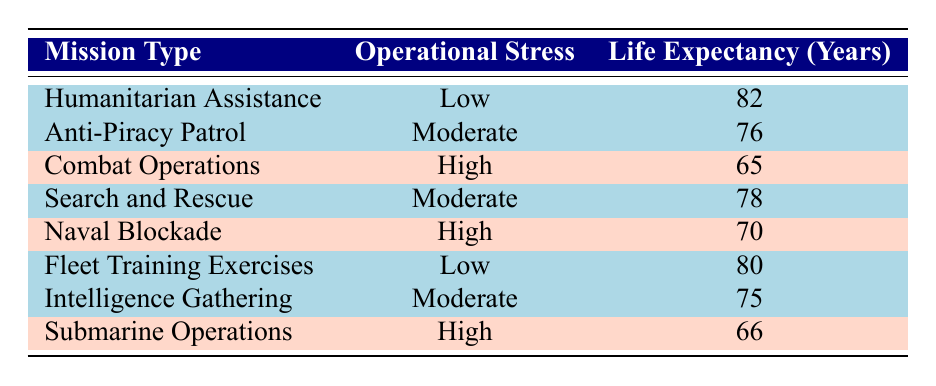What is the life expectancy of naval officers on Humanitarian Assistance missions? From the table, the row for "Humanitarian Assistance" shows the operational stress level as "Low" and the average life expectancy as 82 years.
Answer: 82 What is the average life expectancy for officers in Combat Operations? The table indicates that for "Combat Operations," which has a high operational stress level, the average life expectancy is 65 years.
Answer: 65 Is the life expectancy higher for Fleet Training Exercises than for Anti-Piracy Patrol? Comparing the two: Fleet Training Exercises has an average life expectancy of 80 years and Anti-Piracy Patrol has 76 years. Since 80 is greater than 76, the answer is yes.
Answer: Yes What is the operational stress level associated with Submarine Operations? The table shows that Submarine Operations has an operational stress level categorized as "High."
Answer: High What is the difference in life expectancy between officers in Search and Rescue and those in Naval Blockade missions? The average life expectancy for Search and Rescue is 78 years, while for Naval Blockade it is 70 years. Calculating the difference: 78 - 70 = 8 years.
Answer: 8 Are the life expectancy values for officers in Intelligence Gathering higher than 75 years? The table shows that the average life expectancy for Intelligence Gathering is 75 years, therefore it is not higher than 75.
Answer: No Which mission type has the highest life expectancy? The highest life expectancy can be identified by examining the values in the table; Humanitarian Assistance has the highest at 82 years.
Answer: Humanitarian Assistance If we combine the life expectancy of all high operational stress missions, what is the average life expectancy? The high-stress missions are Combat Operations (65), Naval Blockade (70), and Submarine Operations (66). Their sum is 65 + 70 + 66 = 201. Since there are 3 missions, the average is 201 / 3 = 67 years.
Answer: 67 What mission type has the lowest life expectancy and what is its value? The lowest life expectancy comes from Combat Operations, which is recorded at 65 years in the table.
Answer: Combat Operations, 65 